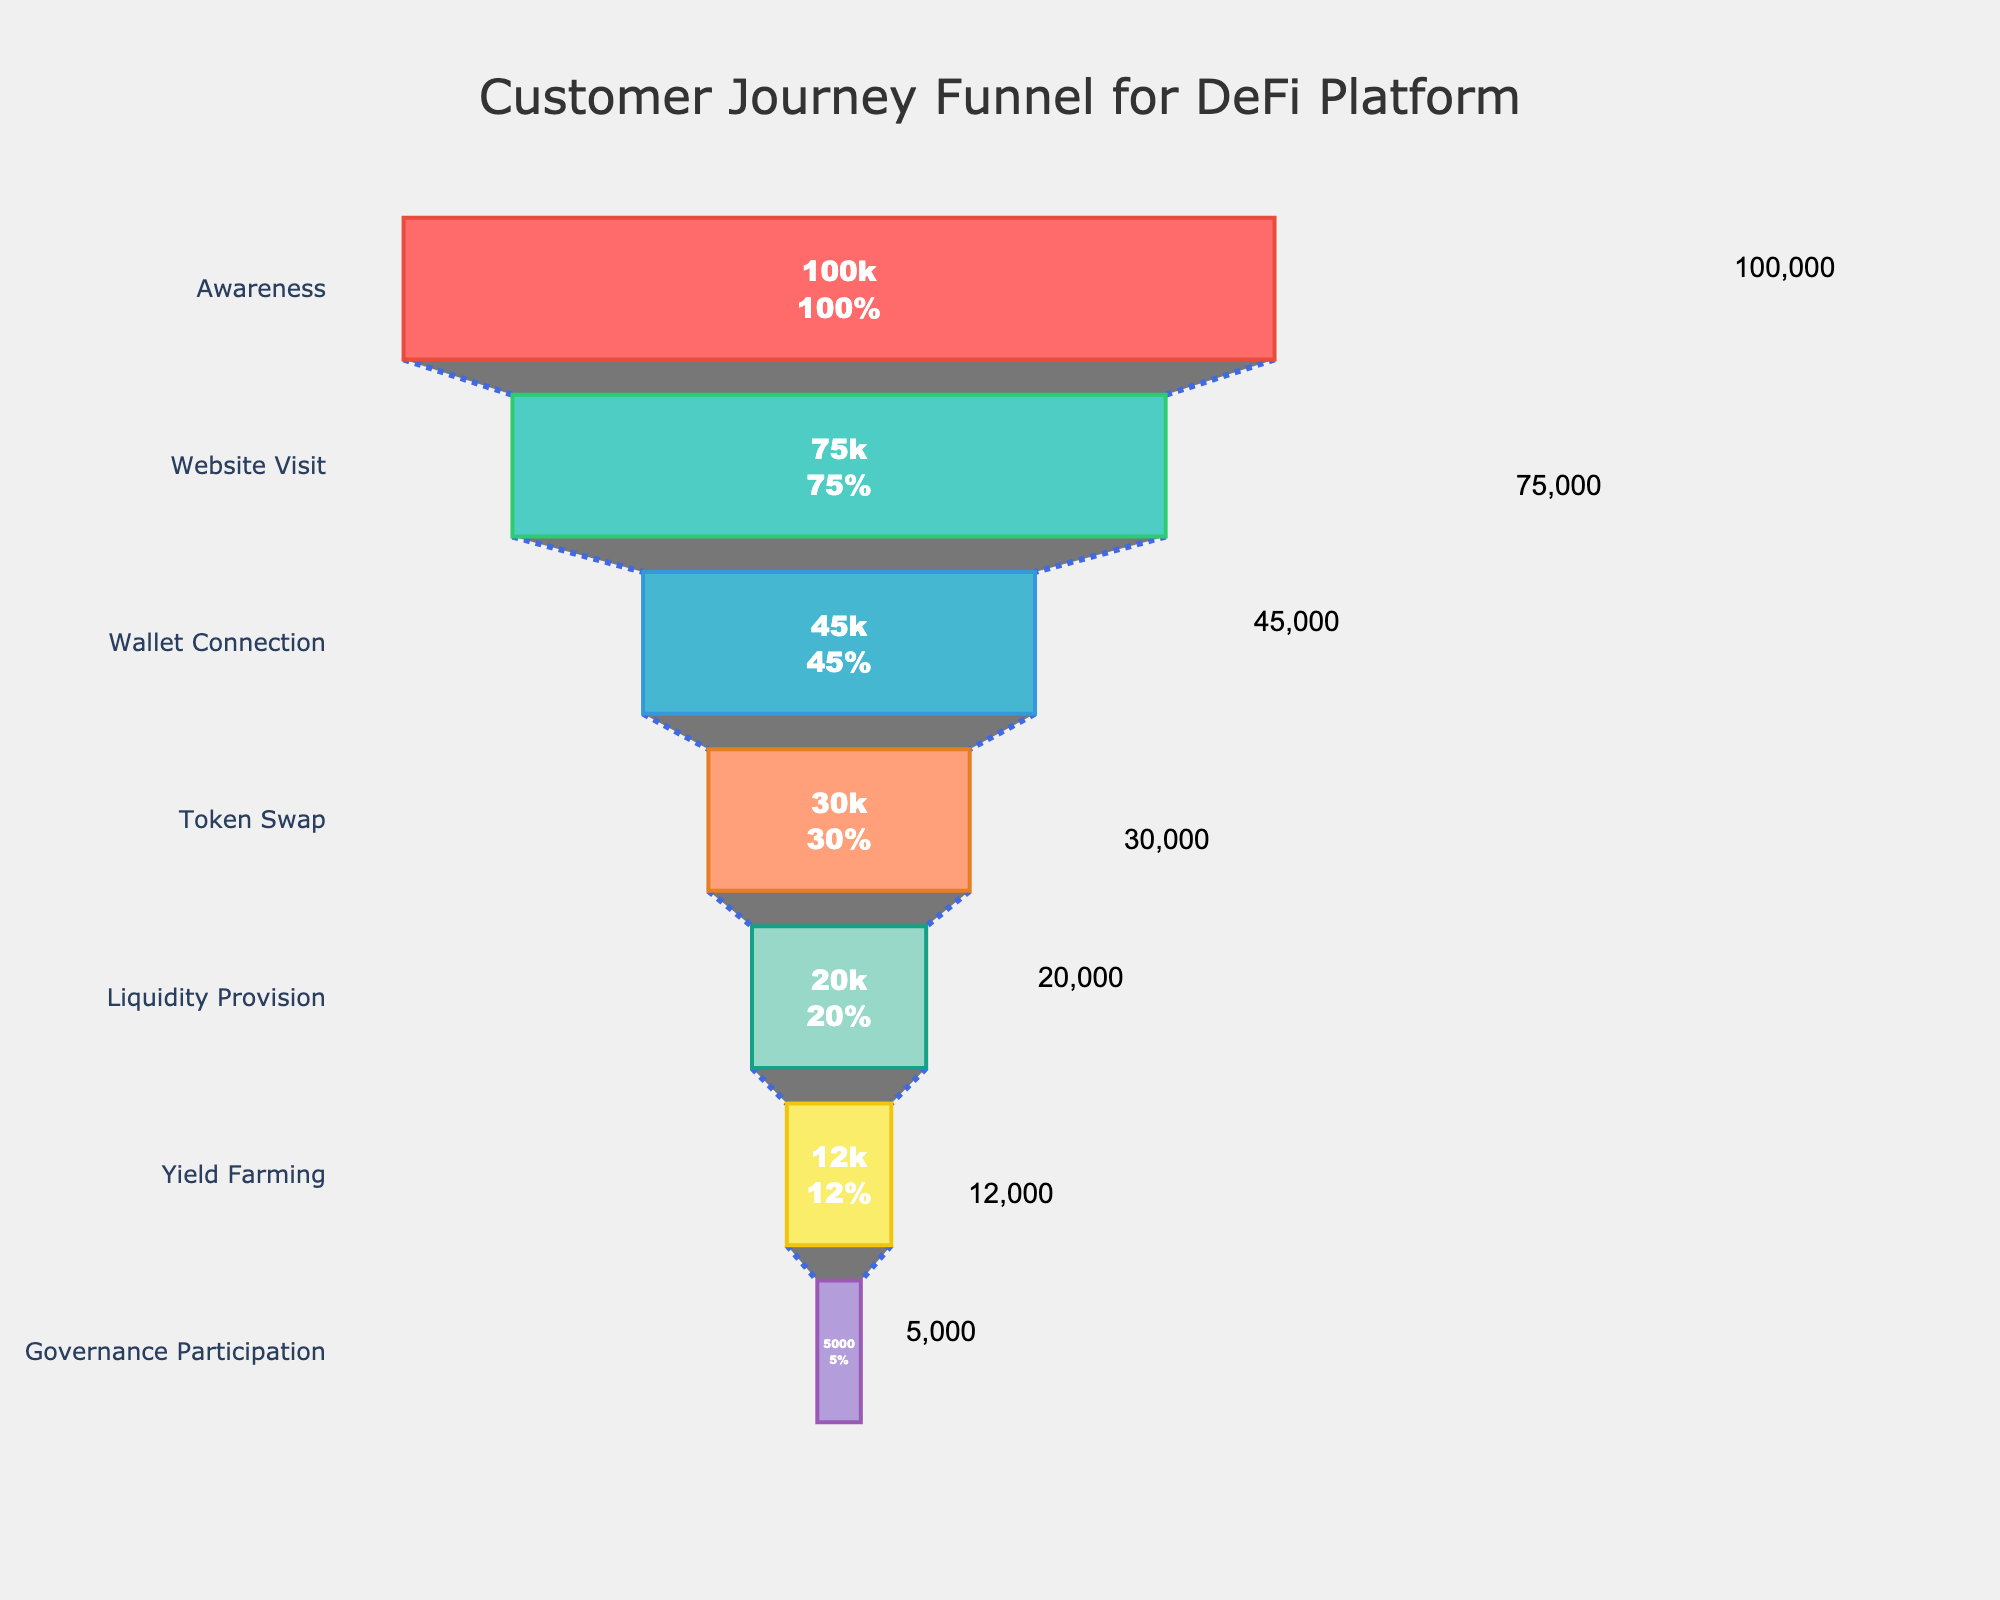What is the title of the funnel chart? The title is typically displayed at the top of the chart. Read the text at the top of the chart to find the title.
Answer: Customer Journey Funnel for DeFi Platform How many stages are there in the funnel chart? Count the different stages or levels present in the funnel chart from top to bottom.
Answer: 7 What is the percentage of users that proceed from the 'Awareness' stage to the 'Website Visit' stage? To find this, divide the number of users at the 'Website Visit' stage by the number of users at the 'Awareness' stage and multiply by 100. Calculation: (75,000/100,000) * 100.
Answer: 75% What is the drop-off rate from the 'Wallet Connection' stage to the 'Token Swap' stage? Subtract the number of users in the 'Token Swap' stage from the 'Wallet Connection' stage and then divide by the number of users in the 'Wallet Connection' stage, finally multiplying by 100. Calculation: ((45,000 - 30,000) / 45,000) * 100.
Answer: 33.33% Which stage has the highest drop-off rate? Calculate the drop-off rate between each consecutive pair of stages by finding the difference in users between stages and dividing by the number of users in the previous stage, the highest value corresponds to the highest drop-off rate.
Answer: Governance Participation Between which two stages is the largest number of users lost? Find the pair of consecutive stages that have the highest absolute difference in the number of users.
Answer: Awareness and Website Visit What is the percentage of 'Awareness' users that reach the 'Governance Participation' stage? Divide the number of users in the 'Governance Participation' stage by the number of users in the 'Awareness' stage and multiply by 100. Calculation: (5,000/100,000) * 100.
Answer: 5% How many more users participate in 'Yield Farming' compared to 'Governance Participation'? Subtract the number of users in 'Governance Participation' stage from the 'Yield Farming' stage. Calculation: 12,000 - 5,000.
Answer: 7,000 Which stages have user numbers lower than 20,000? Identify and list stages where the number of users is less than 20,000 by reading the values associated with each stage.
Answer: Yield Farming, Governance Participation What percentage of users that visit the website proceed to 'Liquidity Provision'? Divide the number of users in 'Liquidity Provision' by the number of users in 'Website Visit' and multiply by 100. Calculation: (20,000 / 75,000) * 100.
Answer: 26.67% 